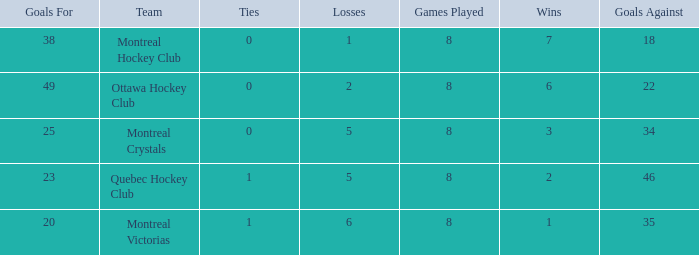What is the total number of goals for when the ties is more than 0, the goals against is more than 35 and the wins is less than 2? 0.0. 